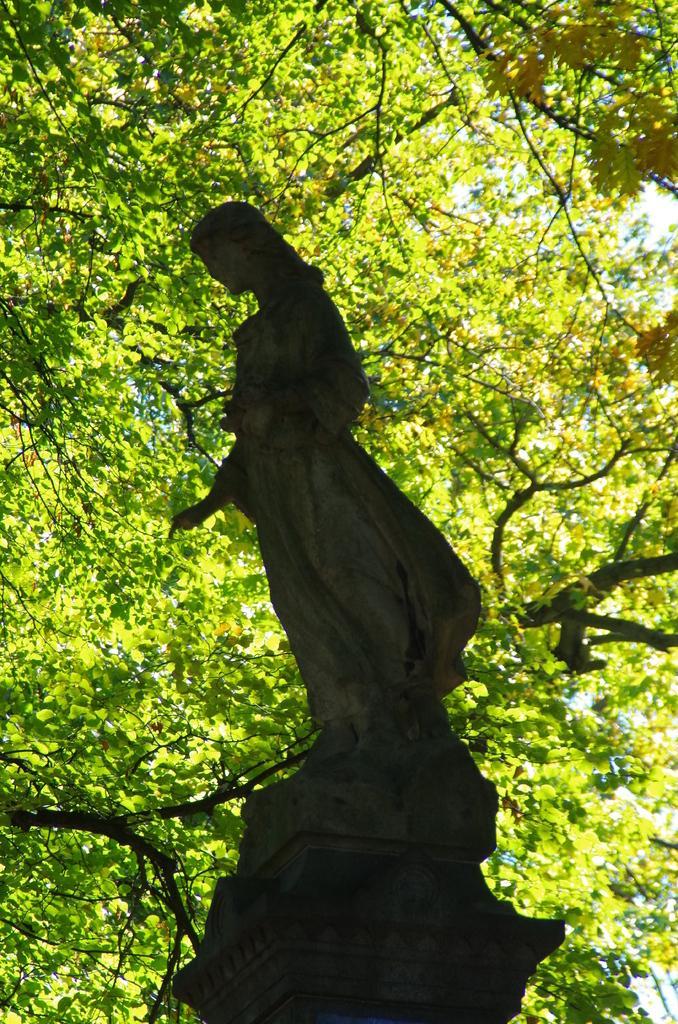Can you describe this image briefly? In this picture I can see a statue and few trees branches in the background. 